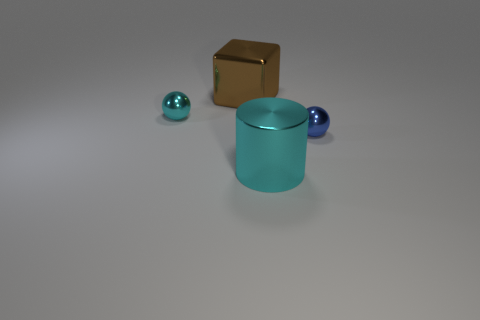There is a big metal thing in front of the small sphere that is to the left of the brown metal thing; what is its color?
Make the answer very short. Cyan. There is a tiny thing that is the same color as the big cylinder; what is it made of?
Your answer should be compact. Metal. What color is the tiny metal object that is on the left side of the big cyan metallic cylinder?
Provide a short and direct response. Cyan. Is the size of the sphere that is behind the blue sphere the same as the tiny blue metallic thing?
Offer a terse response. Yes. There is a ball that is the same color as the metallic cylinder; what size is it?
Your answer should be very brief. Small. Is there a blue metal object of the same size as the blue ball?
Offer a very short reply. No. There is a large thing behind the blue object; does it have the same color as the sphere that is to the left of the large brown metal block?
Provide a short and direct response. No. Is there a shiny thing that has the same color as the metallic cylinder?
Your answer should be compact. Yes. What number of other objects are the same shape as the tiny blue metal thing?
Make the answer very short. 1. The big cyan shiny object in front of the brown object has what shape?
Provide a succinct answer. Cylinder. 